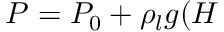<formula> <loc_0><loc_0><loc_500><loc_500>P = P _ { 0 } + \rho _ { l } g ( H</formula> 